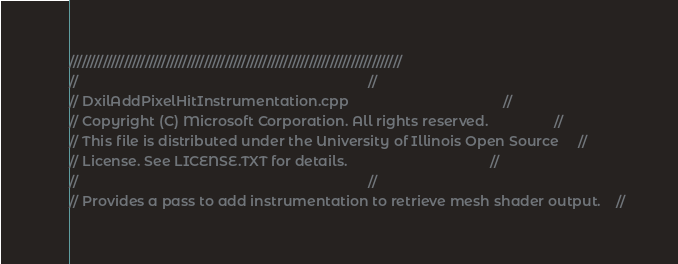Convert code to text. <code><loc_0><loc_0><loc_500><loc_500><_C++_>///////////////////////////////////////////////////////////////////////////////
//                                                                           //
// DxilAddPixelHitInstrumentation.cpp                                        //
// Copyright (C) Microsoft Corporation. All rights reserved.                 //
// This file is distributed under the University of Illinois Open Source     //
// License. See LICENSE.TXT for details.                                     //
//                                                                           //
// Provides a pass to add instrumentation to retrieve mesh shader output.    //</code> 